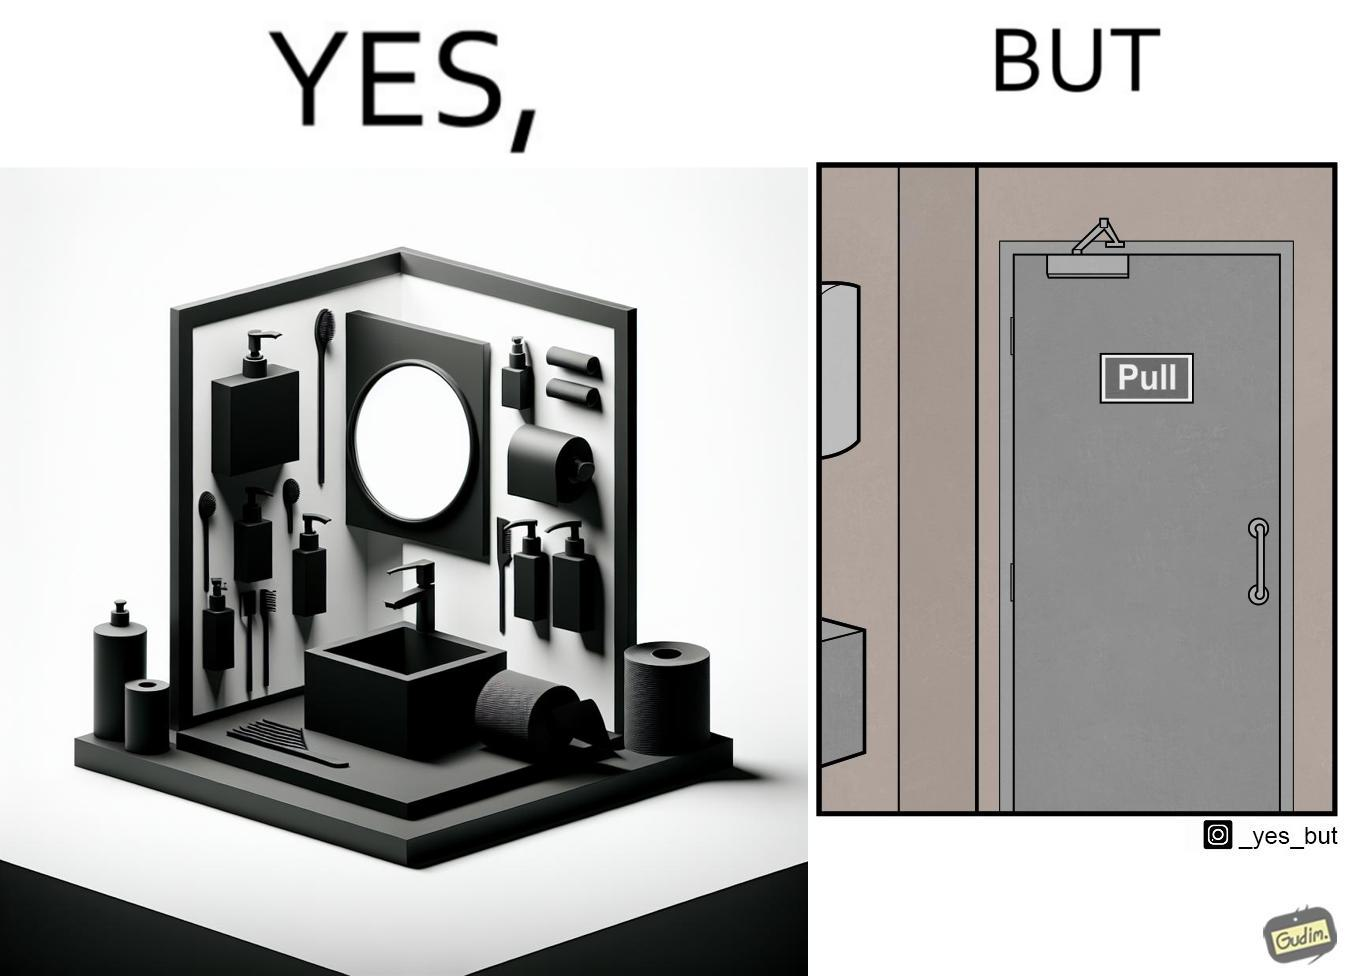Describe the contrast between the left and right parts of this image. In the left part of the image: a basin with different handwashes and paper roll around it to clean hands with a mirror in front In the right part of the image: a door with a pull sign and handle on it 